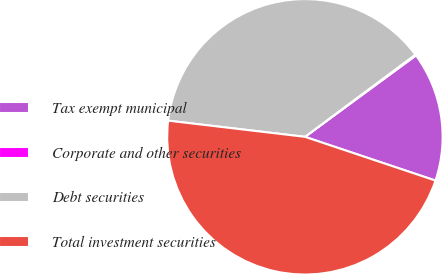Convert chart to OTSL. <chart><loc_0><loc_0><loc_500><loc_500><pie_chart><fcel>Tax exempt municipal<fcel>Corporate and other securities<fcel>Debt securities<fcel>Total investment securities<nl><fcel>15.21%<fcel>0.12%<fcel>37.94%<fcel>46.72%<nl></chart> 